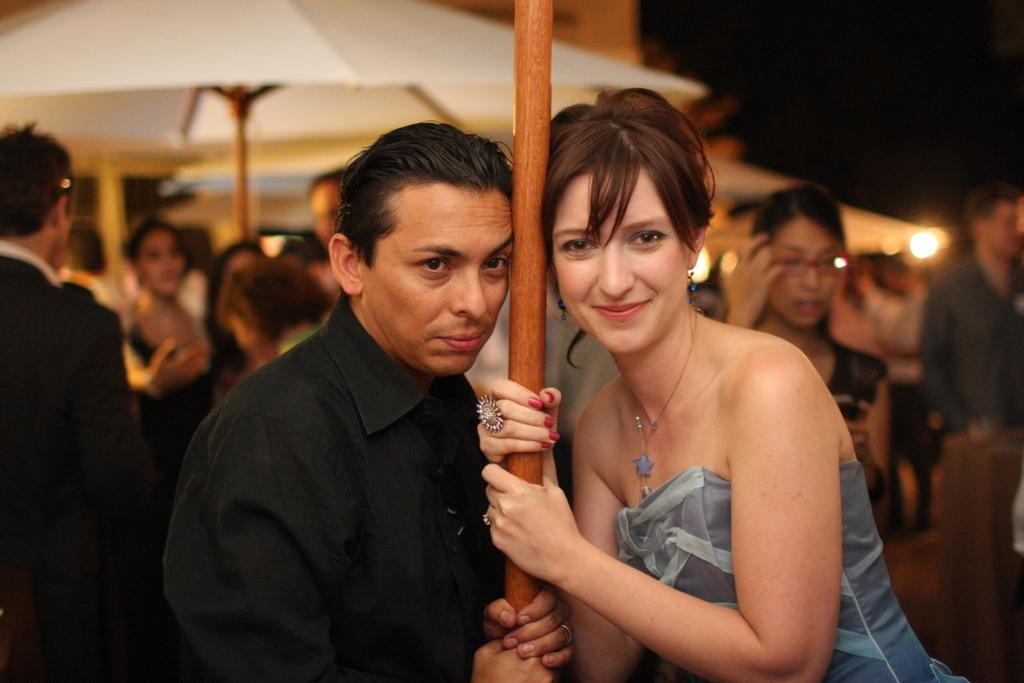Who are the two people in the image? There is a man and a woman in the image. What are the man and woman doing in the image? The man and woman are standing and holding a wooden stick. What can be seen in the background of the image? There is a group of people in the background of the image. What are the people in the background holding? The people in the background are holding umbrellas with wooden sticks. What is the man pointing at with the wooden stick in the image? There is no indication in the image that the man is pointing at anything with the wooden stick. The man and woman are simply holding the wooden stick, and their actions are not specified beyond that. 